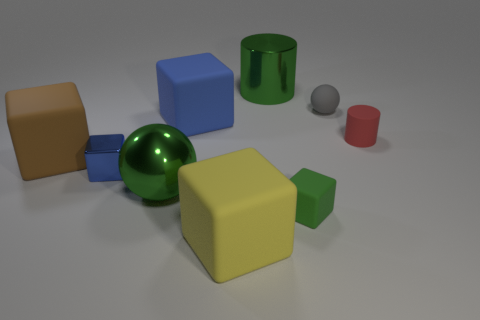Are there an equal number of brown rubber objects that are in front of the small blue cube and large gray shiny objects?
Keep it short and to the point. Yes. How many cubes are small red matte things or yellow things?
Offer a terse response. 1. What color is the small thing that is the same material as the big ball?
Your answer should be compact. Blue. Are the green cylinder and the green object in front of the metallic ball made of the same material?
Make the answer very short. No. What number of objects are big cylinders or blue matte blocks?
Your answer should be compact. 2. There is a small object that is the same color as the big metal sphere; what is it made of?
Keep it short and to the point. Rubber. Is there another large rubber thing of the same shape as the brown rubber object?
Give a very brief answer. Yes. How many matte cylinders are to the left of the big yellow rubber block?
Ensure brevity in your answer.  0. What is the material of the cylinder that is right of the tiny gray rubber sphere behind the small blue block?
Provide a succinct answer. Rubber. There is a green cylinder that is the same size as the yellow thing; what material is it?
Offer a very short reply. Metal. 